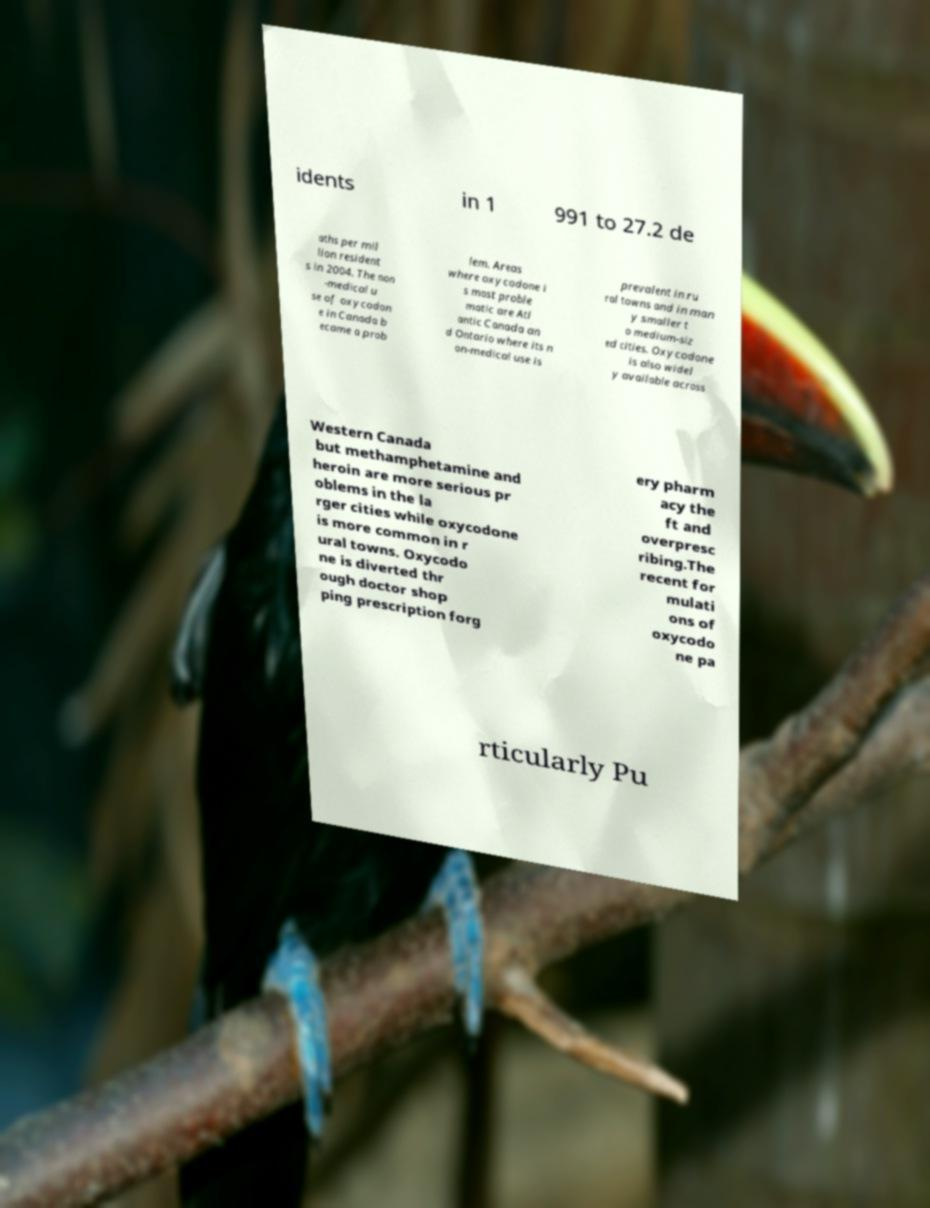Could you assist in decoding the text presented in this image and type it out clearly? idents in 1 991 to 27.2 de aths per mil lion resident s in 2004. The non -medical u se of oxycodon e in Canada b ecame a prob lem. Areas where oxycodone i s most proble matic are Atl antic Canada an d Ontario where its n on-medical use is prevalent in ru ral towns and in man y smaller t o medium-siz ed cities. Oxycodone is also widel y available across Western Canada but methamphetamine and heroin are more serious pr oblems in the la rger cities while oxycodone is more common in r ural towns. Oxycodo ne is diverted thr ough doctor shop ping prescription forg ery pharm acy the ft and overpresc ribing.The recent for mulati ons of oxycodo ne pa rticularly Pu 